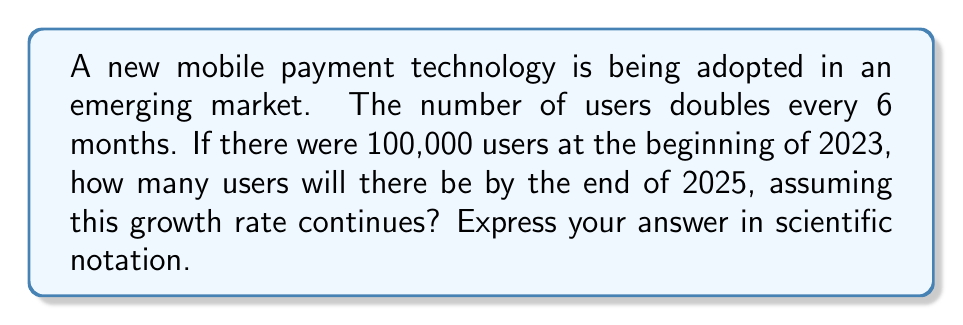Give your solution to this math problem. Let's approach this step-by-step:

1) First, we need to determine how many 6-month periods are there between the start of 2023 and the end of 2025.
   - 2023: 2 periods
   - 2024: 2 periods
   - 2025: 2 periods
   Total: 6 periods

2) Now, we can set up our exponential growth equation:
   $$ N = N_0 \cdot 2^t $$
   Where:
   $N$ is the final number of users
   $N_0$ is the initial number of users (100,000)
   $2$ is our growth factor (doubling each period)
   $t$ is the number of periods (6)

3) Let's plug in our values:
   $$ N = 100,000 \cdot 2^6 $$

4) Calculate $2^6$:
   $$ 2^6 = 64 $$

5) Now our equation looks like:
   $$ N = 100,000 \cdot 64 $$

6) Multiply:
   $$ N = 6,400,000 $$

7) Convert to scientific notation:
   $$ N = 6.4 \times 10^6 $$

Therefore, by the end of 2025, there will be 6.4 million users, or $6.4 \times 10^6$ in scientific notation.
Answer: $6.4 \times 10^6$ 